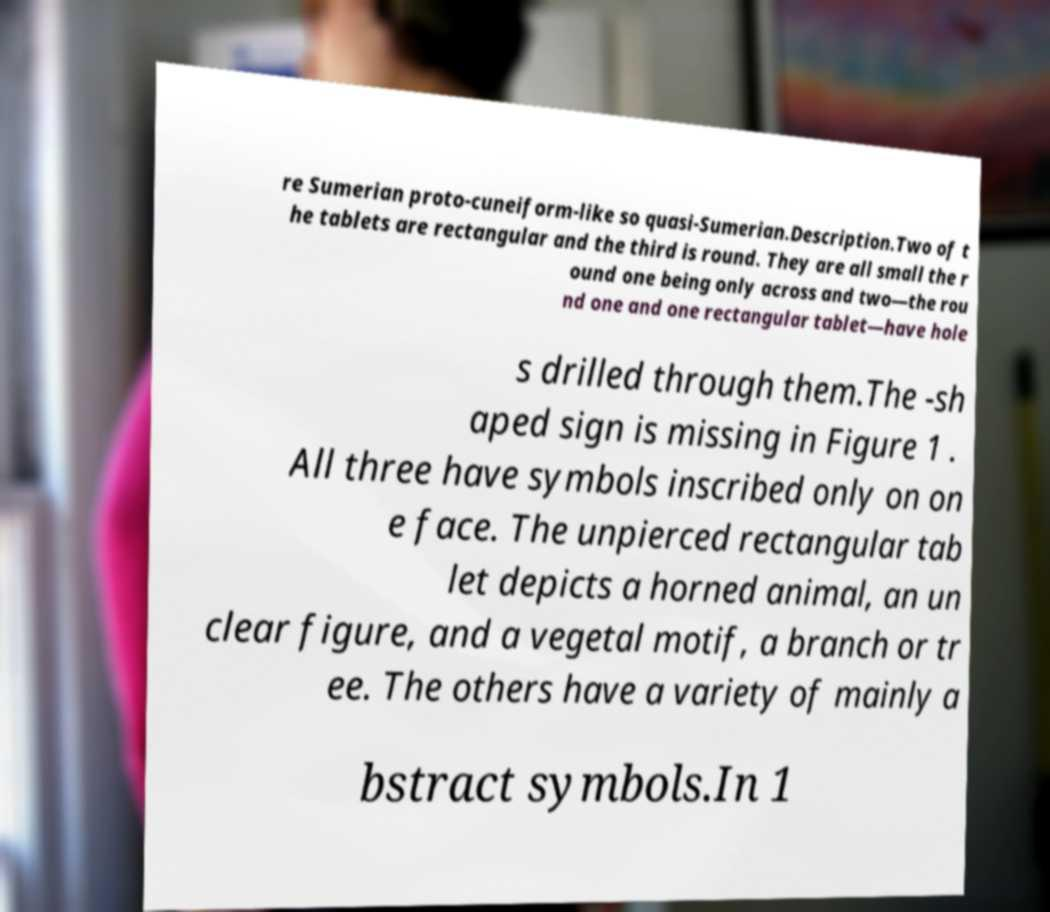Please read and relay the text visible in this image. What does it say? re Sumerian proto-cuneiform-like so quasi-Sumerian.Description.Two of t he tablets are rectangular and the third is round. They are all small the r ound one being only across and two—the rou nd one and one rectangular tablet—have hole s drilled through them.The -sh aped sign is missing in Figure 1 . All three have symbols inscribed only on on e face. The unpierced rectangular tab let depicts a horned animal, an un clear figure, and a vegetal motif, a branch or tr ee. The others have a variety of mainly a bstract symbols.In 1 